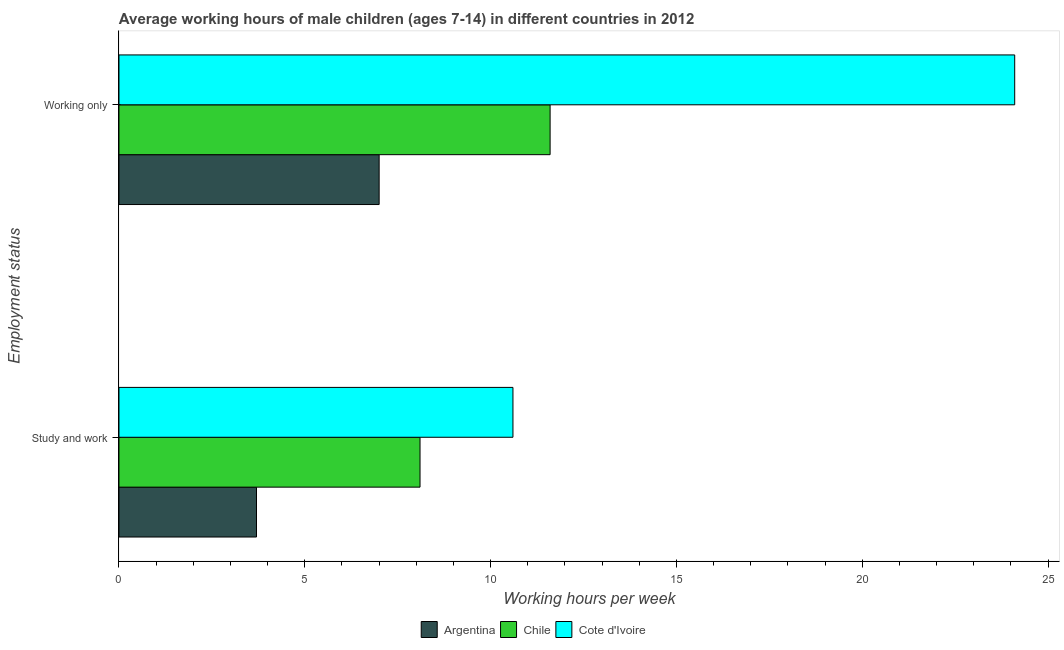How many different coloured bars are there?
Your answer should be very brief. 3. Are the number of bars per tick equal to the number of legend labels?
Your answer should be compact. Yes. How many bars are there on the 1st tick from the top?
Give a very brief answer. 3. What is the label of the 1st group of bars from the top?
Keep it short and to the point. Working only. Across all countries, what is the maximum average working hour of children involved in only work?
Offer a terse response. 24.1. Across all countries, what is the minimum average working hour of children involved in only work?
Your answer should be very brief. 7. In which country was the average working hour of children involved in only work maximum?
Give a very brief answer. Cote d'Ivoire. In which country was the average working hour of children involved in only work minimum?
Ensure brevity in your answer.  Argentina. What is the total average working hour of children involved in only work in the graph?
Your response must be concise. 42.7. What is the difference between the average working hour of children involved in study and work in Cote d'Ivoire and that in Argentina?
Ensure brevity in your answer.  6.9. What is the average average working hour of children involved in study and work per country?
Your response must be concise. 7.47. In how many countries, is the average working hour of children involved in only work greater than 2 hours?
Ensure brevity in your answer.  3. What is the ratio of the average working hour of children involved in study and work in Chile to that in Cote d'Ivoire?
Make the answer very short. 0.76. What does the 2nd bar from the top in Working only represents?
Offer a terse response. Chile. Are all the bars in the graph horizontal?
Offer a very short reply. Yes. How many countries are there in the graph?
Your answer should be very brief. 3. Does the graph contain any zero values?
Make the answer very short. No. How are the legend labels stacked?
Keep it short and to the point. Horizontal. What is the title of the graph?
Make the answer very short. Average working hours of male children (ages 7-14) in different countries in 2012. What is the label or title of the X-axis?
Offer a terse response. Working hours per week. What is the label or title of the Y-axis?
Keep it short and to the point. Employment status. What is the Working hours per week of Argentina in Study and work?
Keep it short and to the point. 3.7. What is the Working hours per week of Chile in Working only?
Your answer should be compact. 11.6. What is the Working hours per week in Cote d'Ivoire in Working only?
Keep it short and to the point. 24.1. Across all Employment status, what is the maximum Working hours per week in Argentina?
Give a very brief answer. 7. Across all Employment status, what is the maximum Working hours per week of Chile?
Make the answer very short. 11.6. Across all Employment status, what is the maximum Working hours per week of Cote d'Ivoire?
Your answer should be very brief. 24.1. Across all Employment status, what is the minimum Working hours per week of Cote d'Ivoire?
Your response must be concise. 10.6. What is the total Working hours per week of Argentina in the graph?
Your answer should be very brief. 10.7. What is the total Working hours per week of Chile in the graph?
Make the answer very short. 19.7. What is the total Working hours per week in Cote d'Ivoire in the graph?
Offer a very short reply. 34.7. What is the difference between the Working hours per week of Argentina in Study and work and the Working hours per week of Cote d'Ivoire in Working only?
Offer a terse response. -20.4. What is the average Working hours per week of Argentina per Employment status?
Offer a very short reply. 5.35. What is the average Working hours per week of Chile per Employment status?
Provide a succinct answer. 9.85. What is the average Working hours per week in Cote d'Ivoire per Employment status?
Keep it short and to the point. 17.35. What is the difference between the Working hours per week of Argentina and Working hours per week of Chile in Study and work?
Keep it short and to the point. -4.4. What is the difference between the Working hours per week in Chile and Working hours per week in Cote d'Ivoire in Study and work?
Offer a very short reply. -2.5. What is the difference between the Working hours per week in Argentina and Working hours per week in Chile in Working only?
Provide a succinct answer. -4.6. What is the difference between the Working hours per week of Argentina and Working hours per week of Cote d'Ivoire in Working only?
Your answer should be compact. -17.1. What is the ratio of the Working hours per week in Argentina in Study and work to that in Working only?
Your answer should be compact. 0.53. What is the ratio of the Working hours per week of Chile in Study and work to that in Working only?
Keep it short and to the point. 0.7. What is the ratio of the Working hours per week in Cote d'Ivoire in Study and work to that in Working only?
Offer a terse response. 0.44. What is the difference between the highest and the second highest Working hours per week of Chile?
Give a very brief answer. 3.5. What is the difference between the highest and the lowest Working hours per week in Argentina?
Offer a very short reply. 3.3. What is the difference between the highest and the lowest Working hours per week of Chile?
Your answer should be compact. 3.5. What is the difference between the highest and the lowest Working hours per week in Cote d'Ivoire?
Keep it short and to the point. 13.5. 